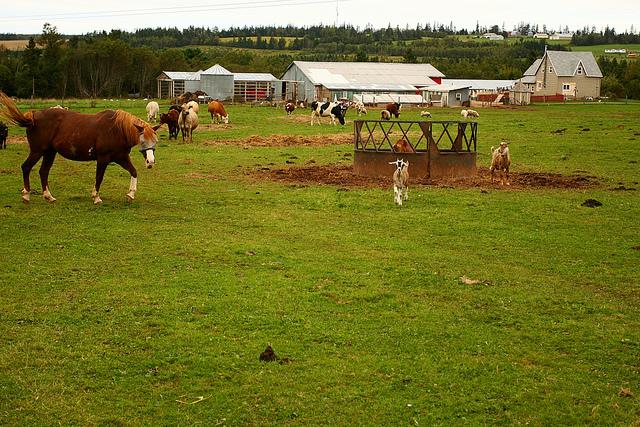How many cows are there?
Keep it brief. 1. How many cows are in the picture?
Give a very brief answer. 6. How many goats do you see directly facing the camera?
Short answer required. 2. Do you see a house?
Write a very short answer. Yes. What is the copyright date on the image?
Short answer required. 0. 